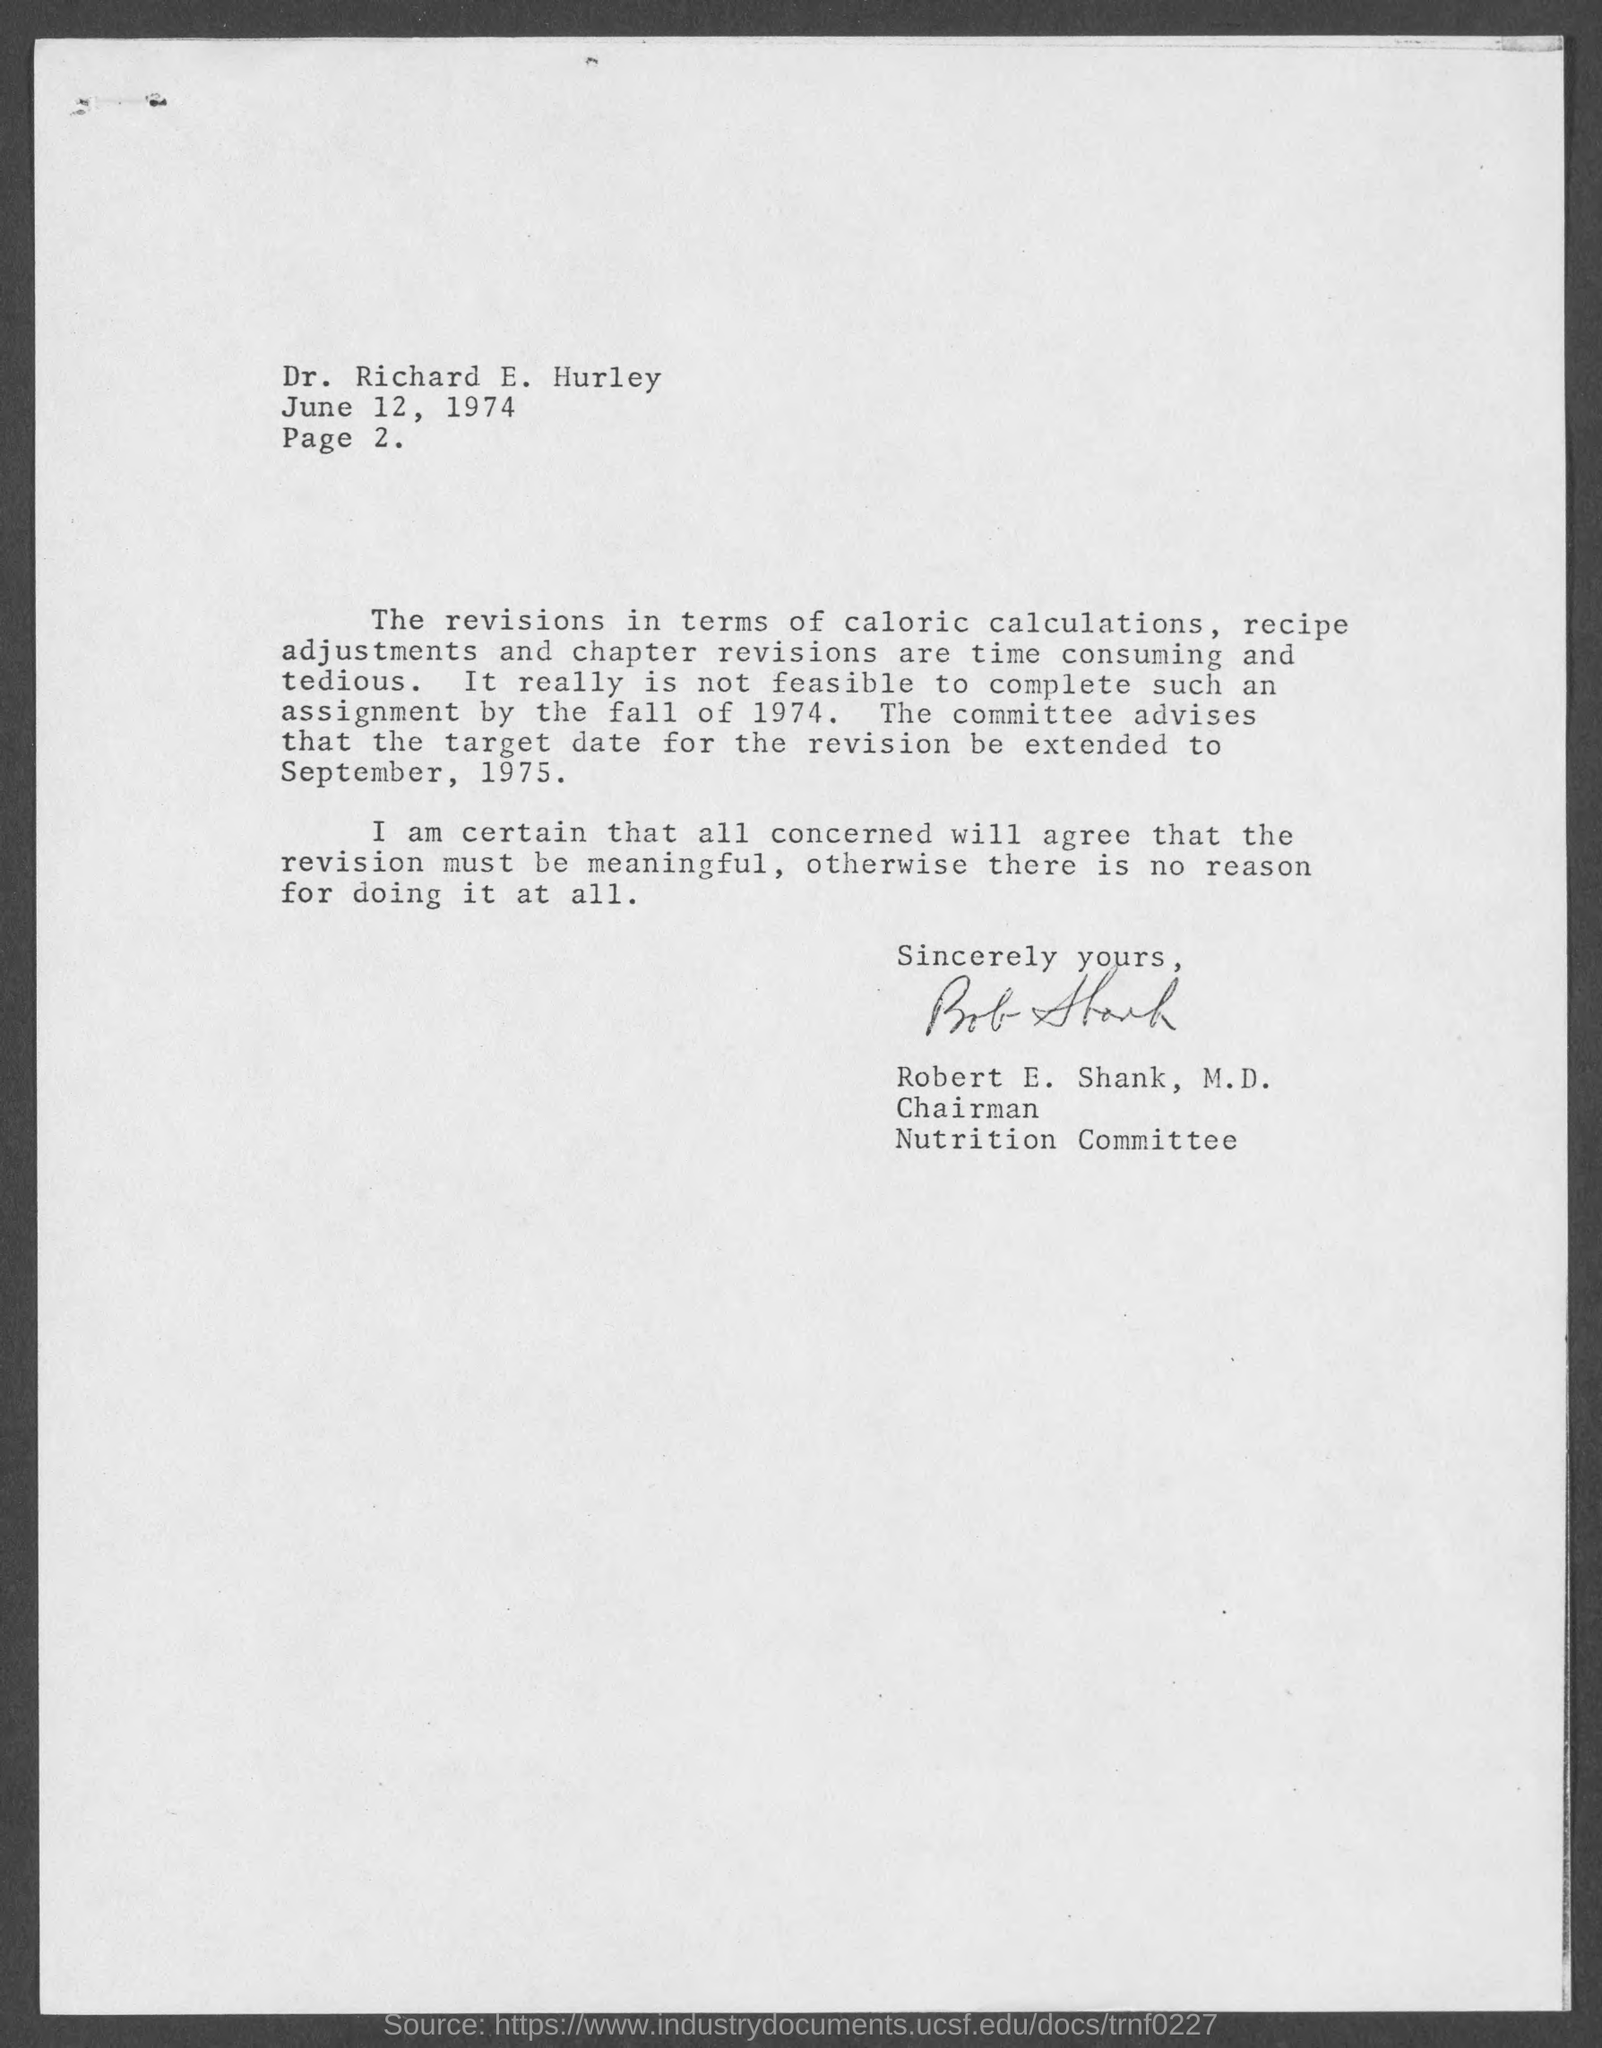To whom is this letter addressed to?
Provide a succinct answer. Richard E. Hurley. Who is this letter from?
Give a very brief answer. Robert E. Shank. The target date for revision be extended to which date?
Provide a short and direct response. September, 1975. 